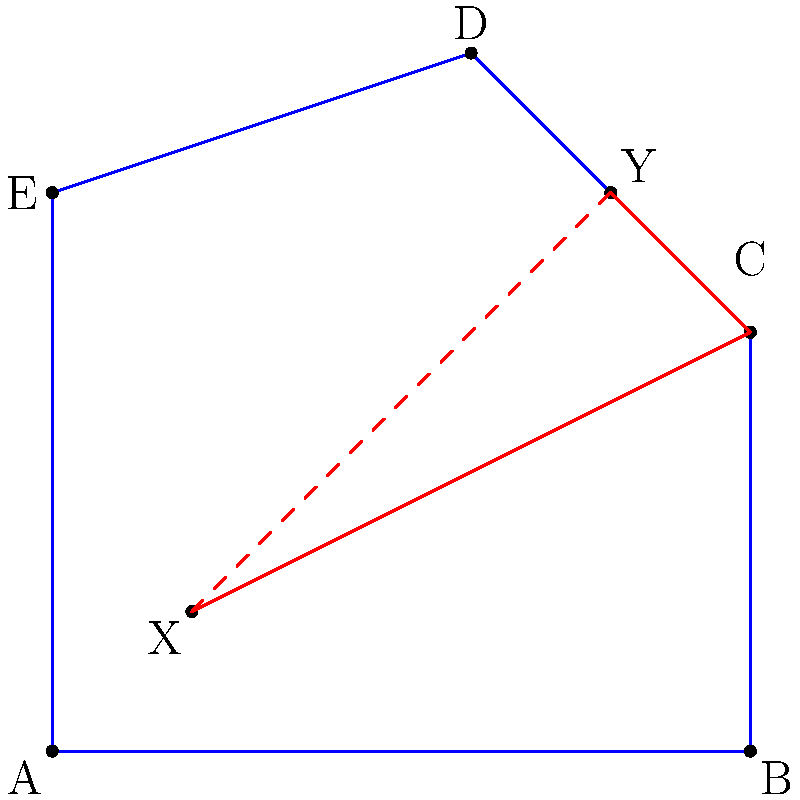In the complex polygon ABCDE representing various stress reduction strategies, points X and Y represent two key relaxation techniques. What is the shortest path between X and Y within the polygon, and how does this relate to optimizing stress management in a high-pressure work environment? To find the shortest path between two points within a polygon, we need to consider both the direct path and paths that pass through the polygon's vertices. This problem can be approached as follows:

1. Direct path: The straight line XY (shown as a red dashed line) passes through the polygon, so it's not a valid path.

2. Paths through vertices: We need to consider paths that go through one or more vertices of the polygon.

3. Observation: The shortest path will be a straight line wherever possible, only bending at vertices when necessary.

4. Analysis: Looking at the polygon, we can see that the path X-C-Y (shown in solid red) is the shortest possible path that stays within the polygon.

5. Verification: Any other path through different vertices (e.g., X-D-Y or X-B-C-Y) would be longer.

In the context of stress management:
- Point X represents the starting stress level.
- Point Y represents the desired lower stress level.
- The polygon represents various constraints and strategies in the work environment.
- The shortest path (X-C-Y) represents the most efficient combination of stress reduction techniques.

By identifying this optimal path, the executive can focus on the most effective strategies (represented by vertex C) to efficiently reduce stress while navigating the complexities of their high-pressure work environment.
Answer: The shortest path is X-C-Y, representing the most efficient stress reduction strategy utilizing key technique C. 